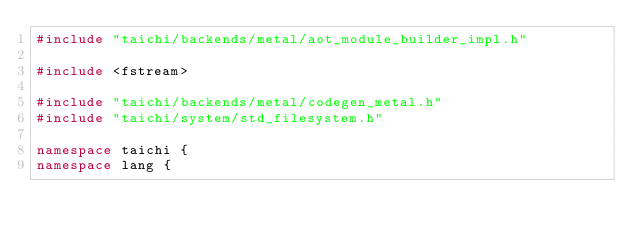<code> <loc_0><loc_0><loc_500><loc_500><_C++_>#include "taichi/backends/metal/aot_module_builder_impl.h"

#include <fstream>

#include "taichi/backends/metal/codegen_metal.h"
#include "taichi/system/std_filesystem.h"

namespace taichi {
namespace lang {</code> 